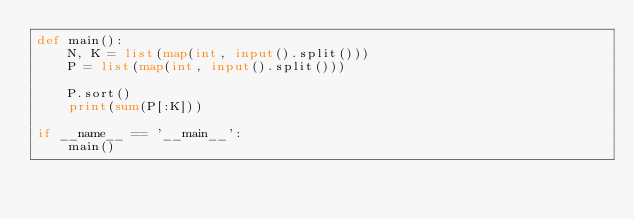Convert code to text. <code><loc_0><loc_0><loc_500><loc_500><_Python_>def main():
    N, K = list(map(int, input().split()))
    P = list(map(int, input().split()))

    P.sort()
    print(sum(P[:K]))

if __name__ == '__main__':
    main()</code> 